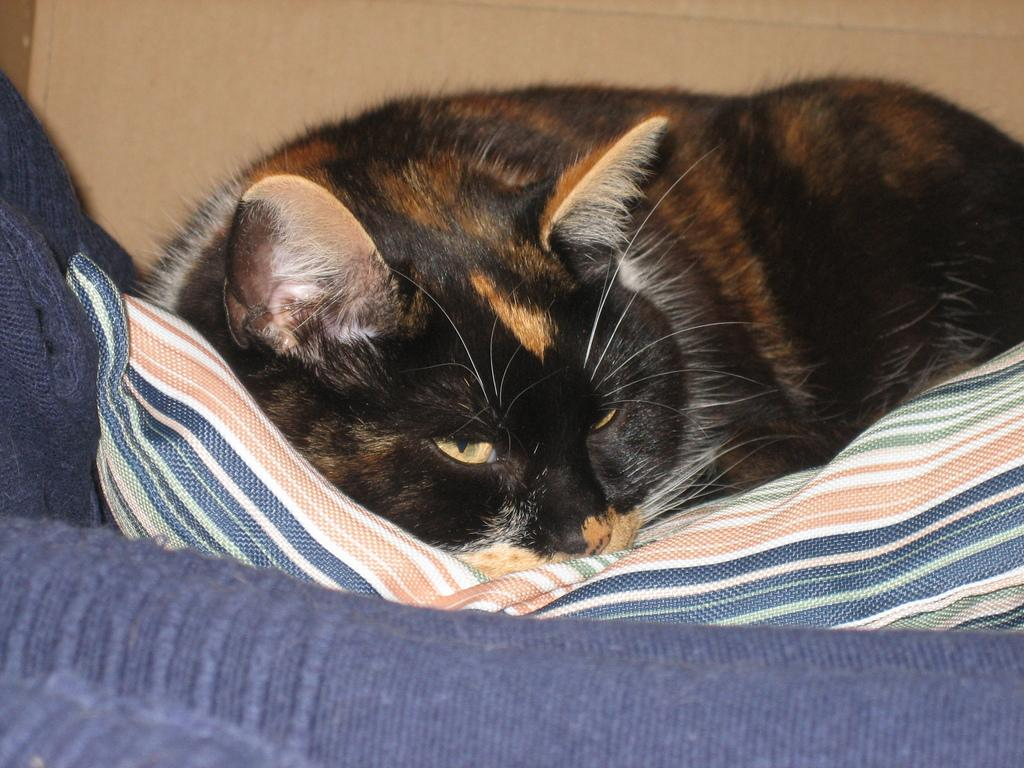What type of animal is in the image? There is a black color cat in the image. What is the cat doing in the image? The cat is laying on a bed sheet. Where is the bed sheet located? The bed sheet is on a couch. What can be seen in the background of the image? There is a wall in the background of the image. What type of connection does the fireman have with the cat in the image? There is no fireman present in the image, so there is no connection between a fireman and the cat. 